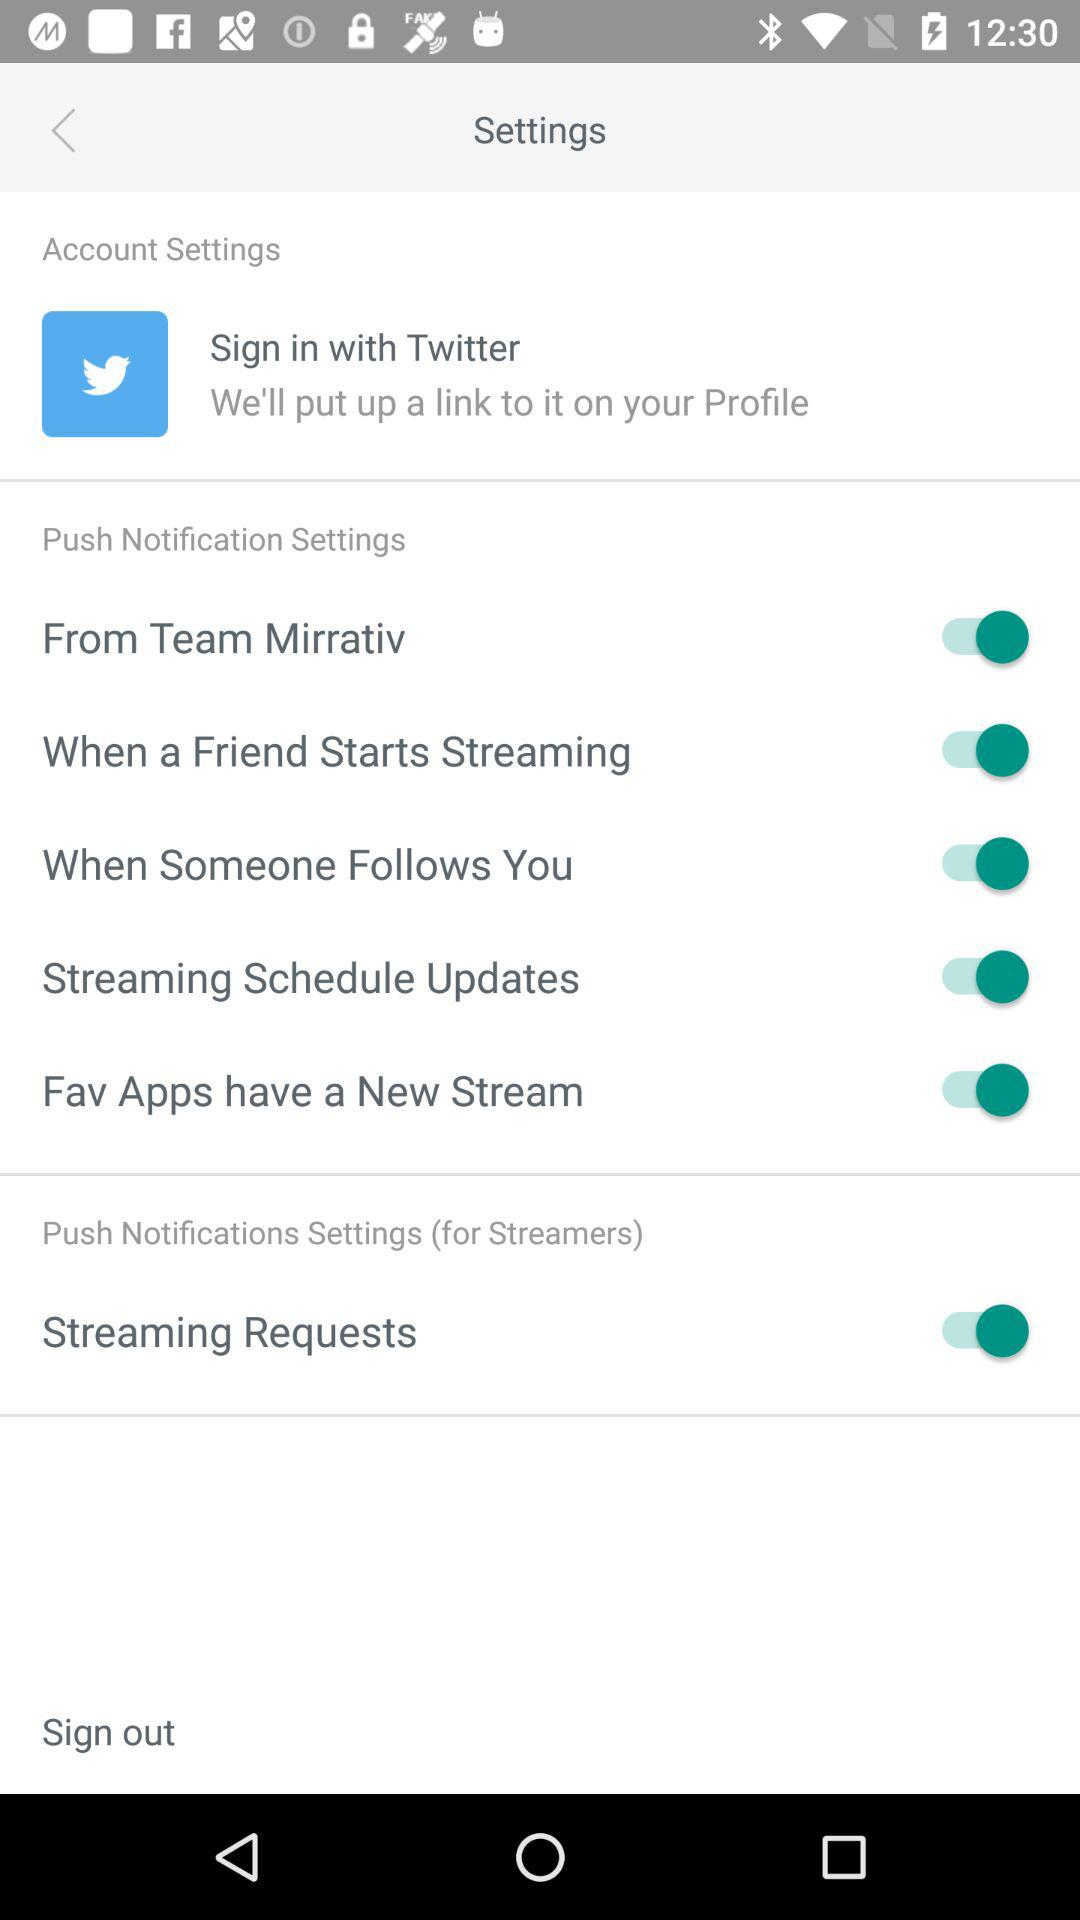How many push notification settings are there?
Answer the question using a single word or phrase. 6 